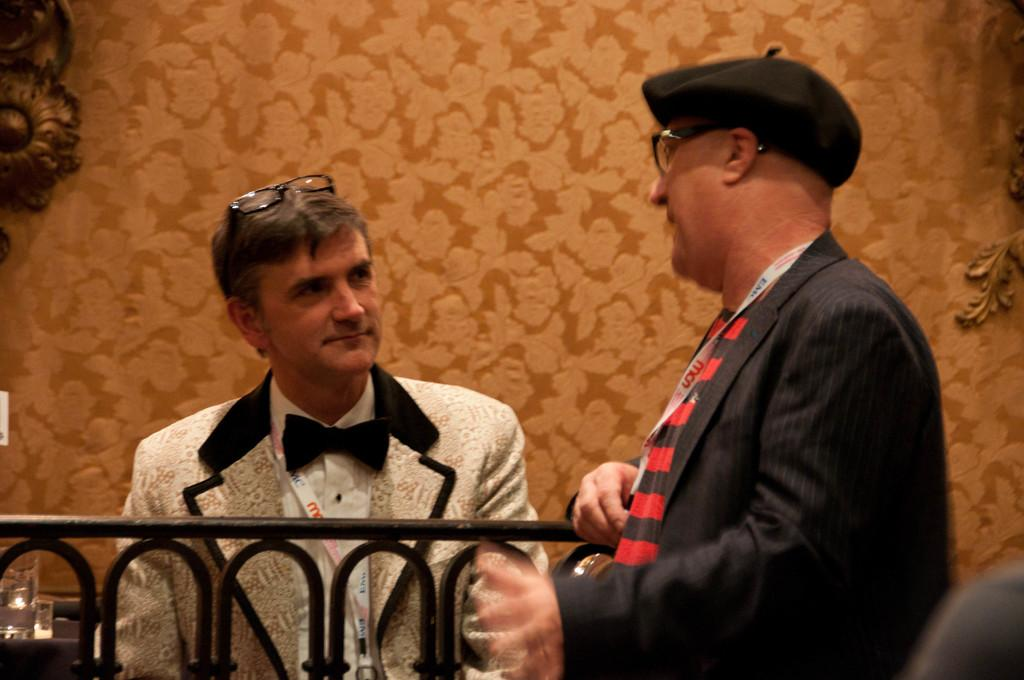How many people are in the image? There are two men in the image. What are the men doing in the image? The men are standing in the image. What are the men wearing in the image? The men are wearing suits in the image. What can be seen in the background of the image? There is a wall in the image. Can you see a zebra in the image? No, there is no zebra present in the image. What type of tool is the man holding in the image? There is no tool, such as a wrench, visible in the image. 